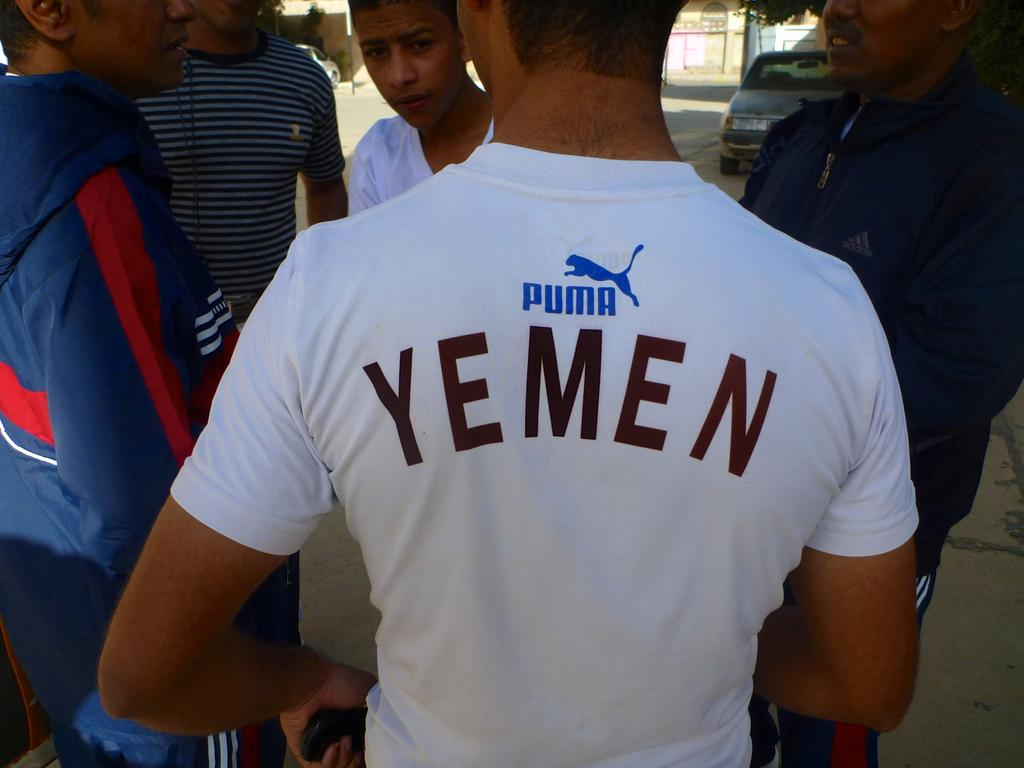What is happening in the image? There are people standing in the image. Can you describe what the person in the front is holding? The person in the front is holding something. What can be seen in the background of the image? There are two cars, a tree, and a wall in the background of the image. What type of garden can be seen in the image? There is no garden present in the image. 